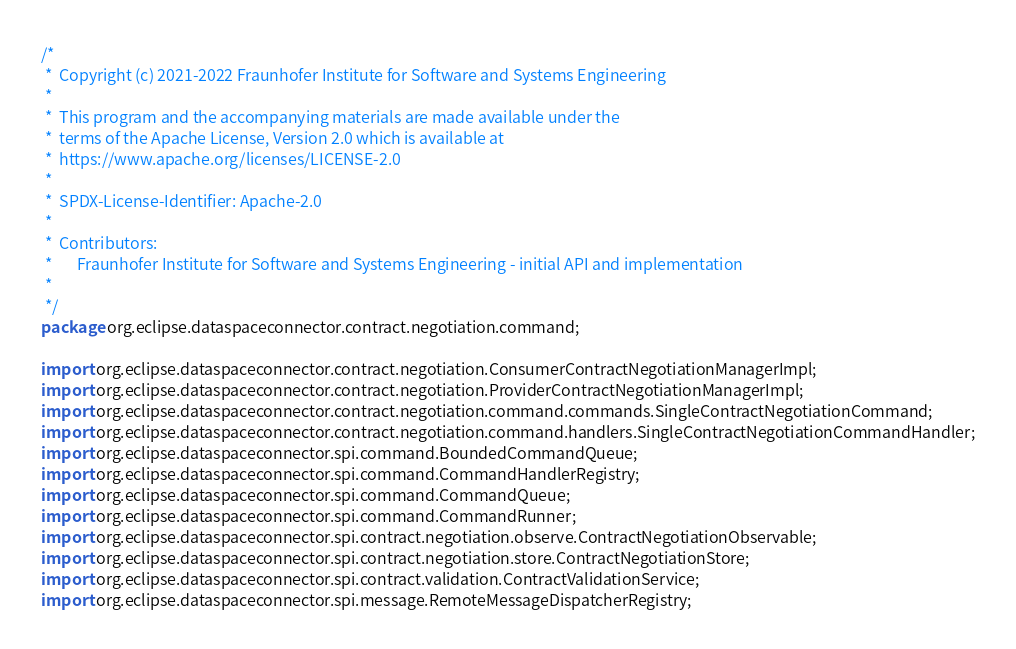<code> <loc_0><loc_0><loc_500><loc_500><_Java_>/*
 *  Copyright (c) 2021-2022 Fraunhofer Institute for Software and Systems Engineering
 *
 *  This program and the accompanying materials are made available under the
 *  terms of the Apache License, Version 2.0 which is available at
 *  https://www.apache.org/licenses/LICENSE-2.0
 *
 *  SPDX-License-Identifier: Apache-2.0
 *
 *  Contributors:
 *       Fraunhofer Institute for Software and Systems Engineering - initial API and implementation
 *
 */
package org.eclipse.dataspaceconnector.contract.negotiation.command;

import org.eclipse.dataspaceconnector.contract.negotiation.ConsumerContractNegotiationManagerImpl;
import org.eclipse.dataspaceconnector.contract.negotiation.ProviderContractNegotiationManagerImpl;
import org.eclipse.dataspaceconnector.contract.negotiation.command.commands.SingleContractNegotiationCommand;
import org.eclipse.dataspaceconnector.contract.negotiation.command.handlers.SingleContractNegotiationCommandHandler;
import org.eclipse.dataspaceconnector.spi.command.BoundedCommandQueue;
import org.eclipse.dataspaceconnector.spi.command.CommandHandlerRegistry;
import org.eclipse.dataspaceconnector.spi.command.CommandQueue;
import org.eclipse.dataspaceconnector.spi.command.CommandRunner;
import org.eclipse.dataspaceconnector.spi.contract.negotiation.observe.ContractNegotiationObservable;
import org.eclipse.dataspaceconnector.spi.contract.negotiation.store.ContractNegotiationStore;
import org.eclipse.dataspaceconnector.spi.contract.validation.ContractValidationService;
import org.eclipse.dataspaceconnector.spi.message.RemoteMessageDispatcherRegistry;</code> 